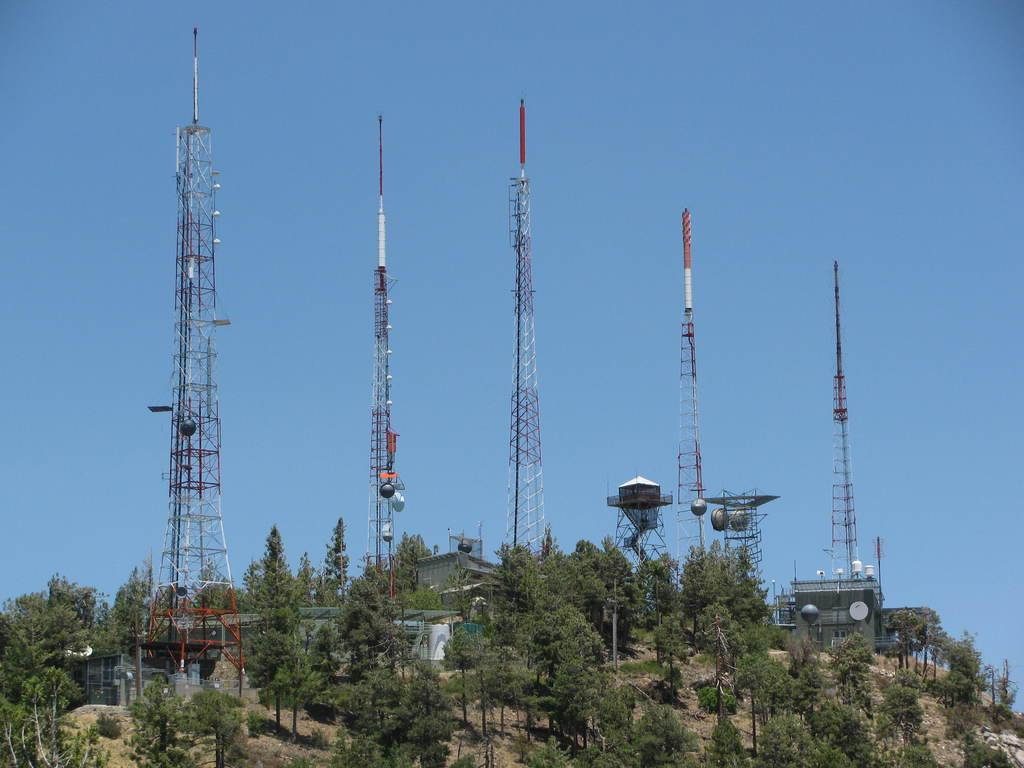What type of natural elements can be seen in the image? There are trees in the image. What man-made structures are present in the image? There are poles and towers in the image. What can be seen in the background of the image? The sky is visible in the background of the image. How many holes can be seen in the trees in the image? There are no holes visible in the trees in the image. What type of sheet is covering the towers in the image? There is no sheet present in the image; it features trees, poles, and towers. 